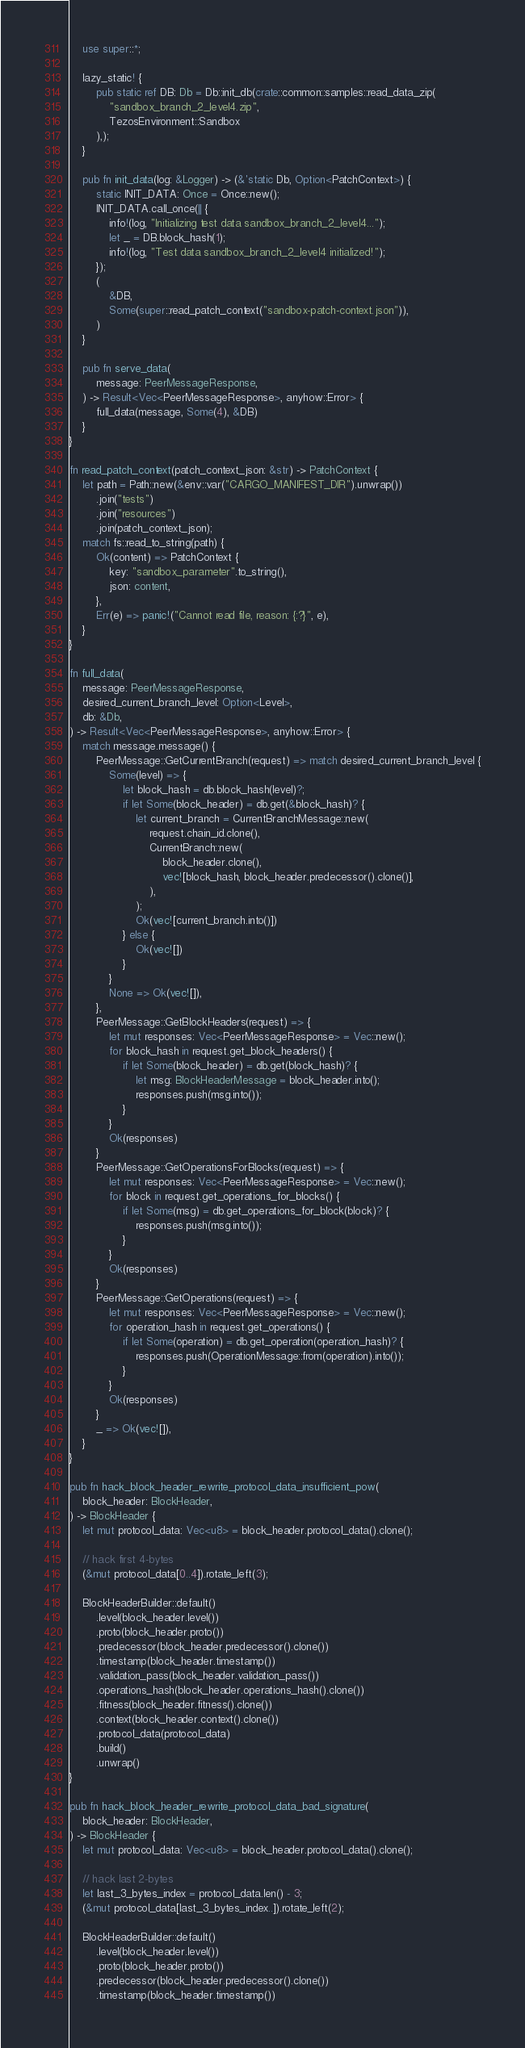Convert code to text. <code><loc_0><loc_0><loc_500><loc_500><_Rust_>
    use super::*;

    lazy_static! {
        pub static ref DB: Db = Db::init_db(crate::common::samples::read_data_zip(
            "sandbox_branch_2_level4.zip",
            TezosEnvironment::Sandbox
        ),);
    }

    pub fn init_data(log: &Logger) -> (&'static Db, Option<PatchContext>) {
        static INIT_DATA: Once = Once::new();
        INIT_DATA.call_once(|| {
            info!(log, "Initializing test data sandbox_branch_2_level4...");
            let _ = DB.block_hash(1);
            info!(log, "Test data sandbox_branch_2_level4 initialized!");
        });
        (
            &DB,
            Some(super::read_patch_context("sandbox-patch-context.json")),
        )
    }

    pub fn serve_data(
        message: PeerMessageResponse,
    ) -> Result<Vec<PeerMessageResponse>, anyhow::Error> {
        full_data(message, Some(4), &DB)
    }
}

fn read_patch_context(patch_context_json: &str) -> PatchContext {
    let path = Path::new(&env::var("CARGO_MANIFEST_DIR").unwrap())
        .join("tests")
        .join("resources")
        .join(patch_context_json);
    match fs::read_to_string(path) {
        Ok(content) => PatchContext {
            key: "sandbox_parameter".to_string(),
            json: content,
        },
        Err(e) => panic!("Cannot read file, reason: {:?}", e),
    }
}

fn full_data(
    message: PeerMessageResponse,
    desired_current_branch_level: Option<Level>,
    db: &Db,
) -> Result<Vec<PeerMessageResponse>, anyhow::Error> {
    match message.message() {
        PeerMessage::GetCurrentBranch(request) => match desired_current_branch_level {
            Some(level) => {
                let block_hash = db.block_hash(level)?;
                if let Some(block_header) = db.get(&block_hash)? {
                    let current_branch = CurrentBranchMessage::new(
                        request.chain_id.clone(),
                        CurrentBranch::new(
                            block_header.clone(),
                            vec![block_hash, block_header.predecessor().clone()],
                        ),
                    );
                    Ok(vec![current_branch.into()])
                } else {
                    Ok(vec![])
                }
            }
            None => Ok(vec![]),
        },
        PeerMessage::GetBlockHeaders(request) => {
            let mut responses: Vec<PeerMessageResponse> = Vec::new();
            for block_hash in request.get_block_headers() {
                if let Some(block_header) = db.get(block_hash)? {
                    let msg: BlockHeaderMessage = block_header.into();
                    responses.push(msg.into());
                }
            }
            Ok(responses)
        }
        PeerMessage::GetOperationsForBlocks(request) => {
            let mut responses: Vec<PeerMessageResponse> = Vec::new();
            for block in request.get_operations_for_blocks() {
                if let Some(msg) = db.get_operations_for_block(block)? {
                    responses.push(msg.into());
                }
            }
            Ok(responses)
        }
        PeerMessage::GetOperations(request) => {
            let mut responses: Vec<PeerMessageResponse> = Vec::new();
            for operation_hash in request.get_operations() {
                if let Some(operation) = db.get_operation(operation_hash)? {
                    responses.push(OperationMessage::from(operation).into());
                }
            }
            Ok(responses)
        }
        _ => Ok(vec![]),
    }
}

pub fn hack_block_header_rewrite_protocol_data_insufficient_pow(
    block_header: BlockHeader,
) -> BlockHeader {
    let mut protocol_data: Vec<u8> = block_header.protocol_data().clone();

    // hack first 4-bytes
    (&mut protocol_data[0..4]).rotate_left(3);

    BlockHeaderBuilder::default()
        .level(block_header.level())
        .proto(block_header.proto())
        .predecessor(block_header.predecessor().clone())
        .timestamp(block_header.timestamp())
        .validation_pass(block_header.validation_pass())
        .operations_hash(block_header.operations_hash().clone())
        .fitness(block_header.fitness().clone())
        .context(block_header.context().clone())
        .protocol_data(protocol_data)
        .build()
        .unwrap()
}

pub fn hack_block_header_rewrite_protocol_data_bad_signature(
    block_header: BlockHeader,
) -> BlockHeader {
    let mut protocol_data: Vec<u8> = block_header.protocol_data().clone();

    // hack last 2-bytes
    let last_3_bytes_index = protocol_data.len() - 3;
    (&mut protocol_data[last_3_bytes_index..]).rotate_left(2);

    BlockHeaderBuilder::default()
        .level(block_header.level())
        .proto(block_header.proto())
        .predecessor(block_header.predecessor().clone())
        .timestamp(block_header.timestamp())</code> 